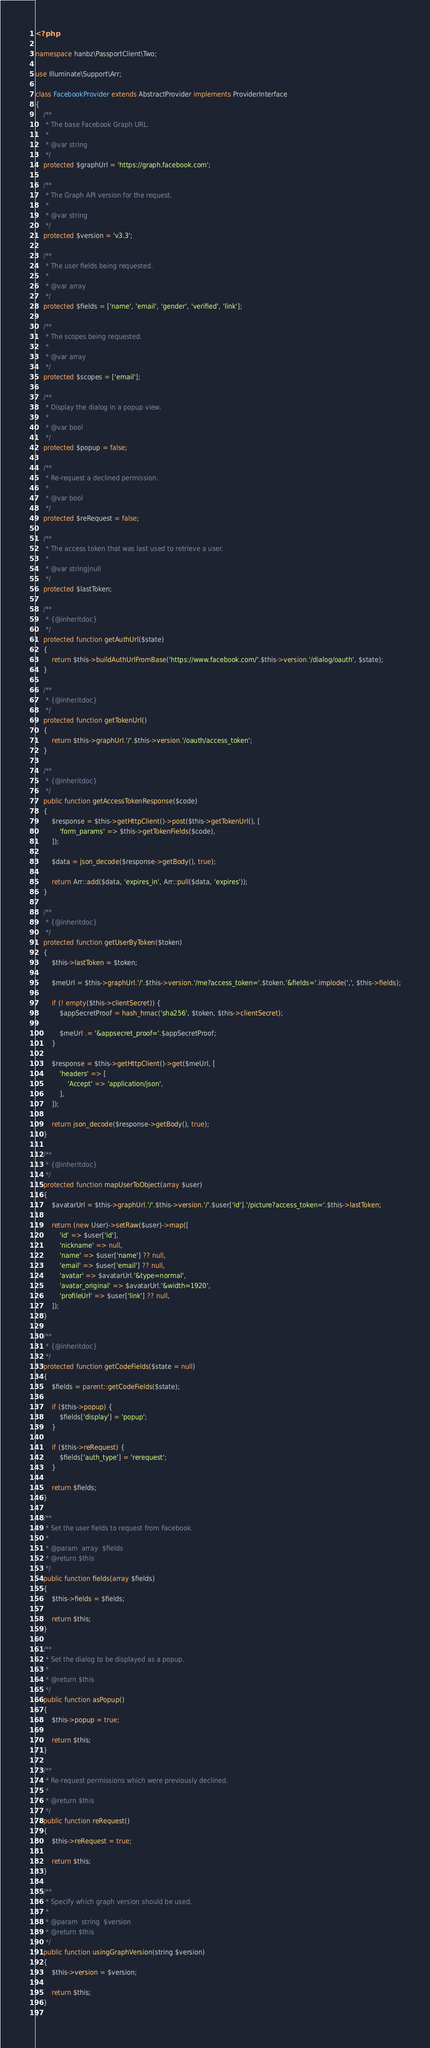Convert code to text. <code><loc_0><loc_0><loc_500><loc_500><_PHP_><?php

namespace hanbz\PassportClient\Two;

use Illuminate\Support\Arr;

class FacebookProvider extends AbstractProvider implements ProviderInterface
{
    /**
     * The base Facebook Graph URL.
     *
     * @var string
     */
    protected $graphUrl = 'https://graph.facebook.com';

    /**
     * The Graph API version for the request.
     *
     * @var string
     */
    protected $version = 'v3.3';

    /**
     * The user fields being requested.
     *
     * @var array
     */
    protected $fields = ['name', 'email', 'gender', 'verified', 'link'];

    /**
     * The scopes being requested.
     *
     * @var array
     */
    protected $scopes = ['email'];

    /**
     * Display the dialog in a popup view.
     *
     * @var bool
     */
    protected $popup = false;

    /**
     * Re-request a declined permission.
     *
     * @var bool
     */
    protected $reRequest = false;

    /**
     * The access token that was last used to retrieve a user.
     *
     * @var string|null
     */
    protected $lastToken;

    /**
     * {@inheritdoc}
     */
    protected function getAuthUrl($state)
    {
        return $this->buildAuthUrlFromBase('https://www.facebook.com/'.$this->version.'/dialog/oauth', $state);
    }

    /**
     * {@inheritdoc}
     */
    protected function getTokenUrl()
    {
        return $this->graphUrl.'/'.$this->version.'/oauth/access_token';
    }

    /**
     * {@inheritdoc}
     */
    public function getAccessTokenResponse($code)
    {
        $response = $this->getHttpClient()->post($this->getTokenUrl(), [
            'form_params' => $this->getTokenFields($code),
        ]);

        $data = json_decode($response->getBody(), true);

        return Arr::add($data, 'expires_in', Arr::pull($data, 'expires'));
    }

    /**
     * {@inheritdoc}
     */
    protected function getUserByToken($token)
    {
        $this->lastToken = $token;

        $meUrl = $this->graphUrl.'/'.$this->version.'/me?access_token='.$token.'&fields='.implode(',', $this->fields);

        if (! empty($this->clientSecret)) {
            $appSecretProof = hash_hmac('sha256', $token, $this->clientSecret);

            $meUrl .= '&appsecret_proof='.$appSecretProof;
        }

        $response = $this->getHttpClient()->get($meUrl, [
            'headers' => [
                'Accept' => 'application/json',
            ],
        ]);

        return json_decode($response->getBody(), true);
    }

    /**
     * {@inheritdoc}
     */
    protected function mapUserToObject(array $user)
    {
        $avatarUrl = $this->graphUrl.'/'.$this->version.'/'.$user['id'].'/picture?access_token='.$this->lastToken;

        return (new User)->setRaw($user)->map([
            'id' => $user['id'],
            'nickname' => null,
            'name' => $user['name'] ?? null,
            'email' => $user['email'] ?? null,
            'avatar' => $avatarUrl.'&type=normal',
            'avatar_original' => $avatarUrl.'&width=1920',
            'profileUrl' => $user['link'] ?? null,
        ]);
    }

    /**
     * {@inheritdoc}
     */
    protected function getCodeFields($state = null)
    {
        $fields = parent::getCodeFields($state);

        if ($this->popup) {
            $fields['display'] = 'popup';
        }

        if ($this->reRequest) {
            $fields['auth_type'] = 'rerequest';
        }

        return $fields;
    }

    /**
     * Set the user fields to request from Facebook.
     *
     * @param  array  $fields
     * @return $this
     */
    public function fields(array $fields)
    {
        $this->fields = $fields;

        return $this;
    }

    /**
     * Set the dialog to be displayed as a popup.
     *
     * @return $this
     */
    public function asPopup()
    {
        $this->popup = true;

        return $this;
    }

    /**
     * Re-request permissions which were previously declined.
     *
     * @return $this
     */
    public function reRequest()
    {
        $this->reRequest = true;

        return $this;
    }

    /**
     * Specify which graph version should be used.
     *
     * @param  string  $version
     * @return $this
     */
    public function usingGraphVersion(string $version)
    {
        $this->version = $version;

        return $this;
    }
}
</code> 